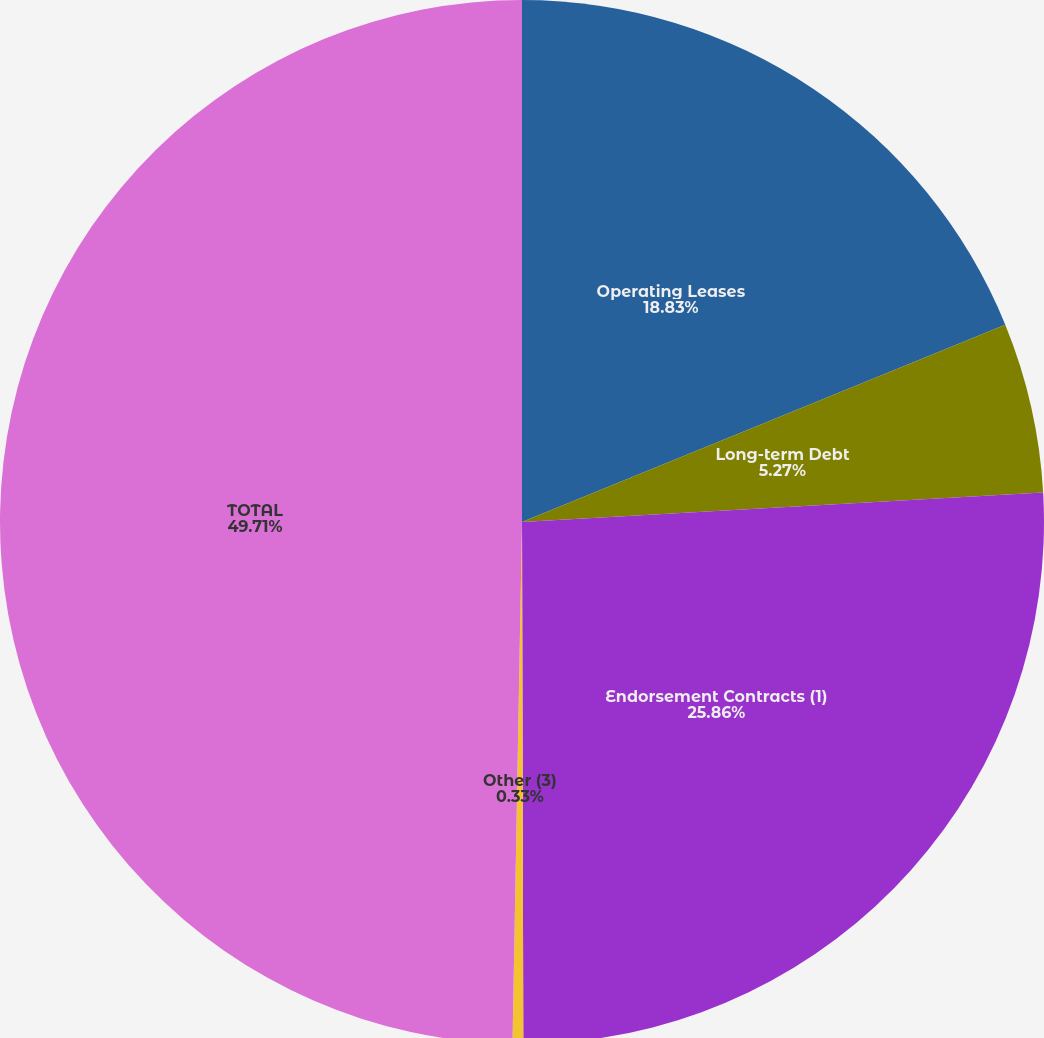Convert chart. <chart><loc_0><loc_0><loc_500><loc_500><pie_chart><fcel>Operating Leases<fcel>Long-term Debt<fcel>Endorsement Contracts (1)<fcel>Other (3)<fcel>TOTAL<nl><fcel>18.83%<fcel>5.27%<fcel>25.86%<fcel>0.33%<fcel>49.71%<nl></chart> 